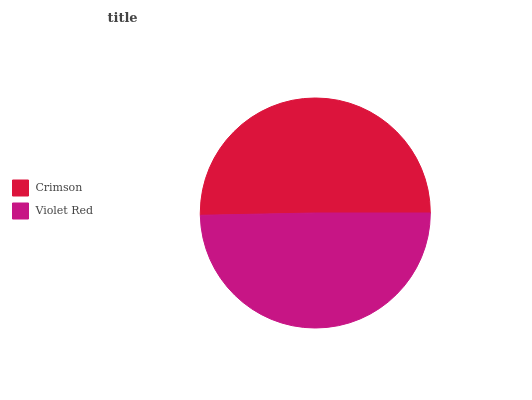Is Violet Red the minimum?
Answer yes or no. Yes. Is Crimson the maximum?
Answer yes or no. Yes. Is Violet Red the maximum?
Answer yes or no. No. Is Crimson greater than Violet Red?
Answer yes or no. Yes. Is Violet Red less than Crimson?
Answer yes or no. Yes. Is Violet Red greater than Crimson?
Answer yes or no. No. Is Crimson less than Violet Red?
Answer yes or no. No. Is Crimson the high median?
Answer yes or no. Yes. Is Violet Red the low median?
Answer yes or no. Yes. Is Violet Red the high median?
Answer yes or no. No. Is Crimson the low median?
Answer yes or no. No. 